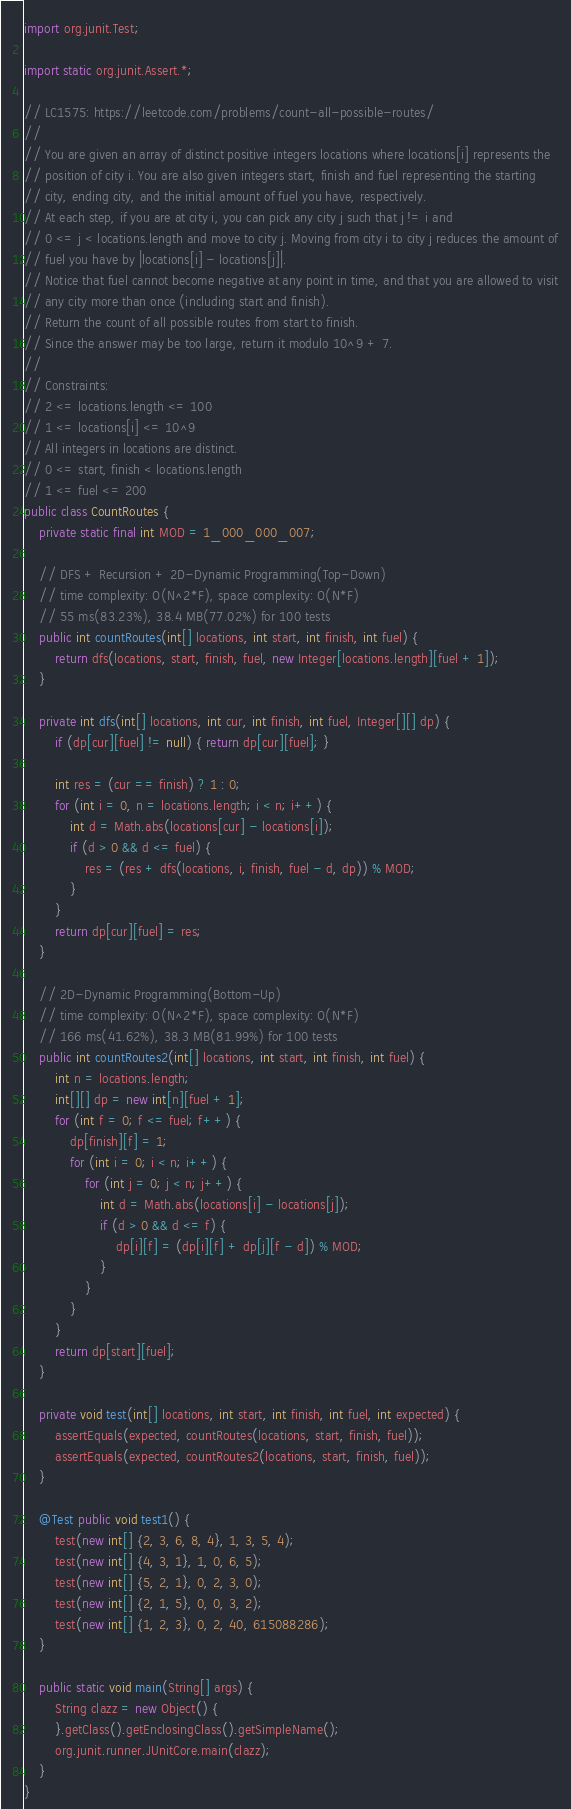<code> <loc_0><loc_0><loc_500><loc_500><_Java_>import org.junit.Test;

import static org.junit.Assert.*;

// LC1575: https://leetcode.com/problems/count-all-possible-routes/
//
// You are given an array of distinct positive integers locations where locations[i] represents the
// position of city i. You are also given integers start, finish and fuel representing the starting
// city, ending city, and the initial amount of fuel you have, respectively.
// At each step, if you are at city i, you can pick any city j such that j != i and
// 0 <= j < locations.length and move to city j. Moving from city i to city j reduces the amount of
// fuel you have by |locations[i] - locations[j]|.
// Notice that fuel cannot become negative at any point in time, and that you are allowed to visit
// any city more than once (including start and finish).
// Return the count of all possible routes from start to finish.
// Since the answer may be too large, return it modulo 10^9 + 7.
//
// Constraints:
// 2 <= locations.length <= 100
// 1 <= locations[i] <= 10^9
// All integers in locations are distinct.
// 0 <= start, finish < locations.length
// 1 <= fuel <= 200
public class CountRoutes {
    private static final int MOD = 1_000_000_007;

    // DFS + Recursion + 2D-Dynamic Programming(Top-Down)
    // time complexity: O(N^2*F), space complexity: O(N*F)
    // 55 ms(83.23%), 38.4 MB(77.02%) for 100 tests
    public int countRoutes(int[] locations, int start, int finish, int fuel) {
        return dfs(locations, start, finish, fuel, new Integer[locations.length][fuel + 1]);
    }

    private int dfs(int[] locations, int cur, int finish, int fuel, Integer[][] dp) {
        if (dp[cur][fuel] != null) { return dp[cur][fuel]; }

        int res = (cur == finish) ? 1 : 0;
        for (int i = 0, n = locations.length; i < n; i++) {
            int d = Math.abs(locations[cur] - locations[i]);
            if (d > 0 && d <= fuel) {
                res = (res + dfs(locations, i, finish, fuel - d, dp)) % MOD;
            }
        }
        return dp[cur][fuel] = res;
    }

    // 2D-Dynamic Programming(Bottom-Up)
    // time complexity: O(N^2*F), space complexity: O(N*F)
    // 166 ms(41.62%), 38.3 MB(81.99%) for 100 tests
    public int countRoutes2(int[] locations, int start, int finish, int fuel) {
        int n = locations.length;
        int[][] dp = new int[n][fuel + 1];
        for (int f = 0; f <= fuel; f++) {
            dp[finish][f] = 1;
            for (int i = 0; i < n; i++) {
                for (int j = 0; j < n; j++) {
                    int d = Math.abs(locations[i] - locations[j]);
                    if (d > 0 && d <= f) {
                        dp[i][f] = (dp[i][f] + dp[j][f - d]) % MOD;
                    }
                }
            }
        }
        return dp[start][fuel];
    }

    private void test(int[] locations, int start, int finish, int fuel, int expected) {
        assertEquals(expected, countRoutes(locations, start, finish, fuel));
        assertEquals(expected, countRoutes2(locations, start, finish, fuel));
    }

    @Test public void test1() {
        test(new int[] {2, 3, 6, 8, 4}, 1, 3, 5, 4);
        test(new int[] {4, 3, 1}, 1, 0, 6, 5);
        test(new int[] {5, 2, 1}, 0, 2, 3, 0);
        test(new int[] {2, 1, 5}, 0, 0, 3, 2);
        test(new int[] {1, 2, 3}, 0, 2, 40, 615088286);
    }

    public static void main(String[] args) {
        String clazz = new Object() {
        }.getClass().getEnclosingClass().getSimpleName();
        org.junit.runner.JUnitCore.main(clazz);
    }
}
</code> 